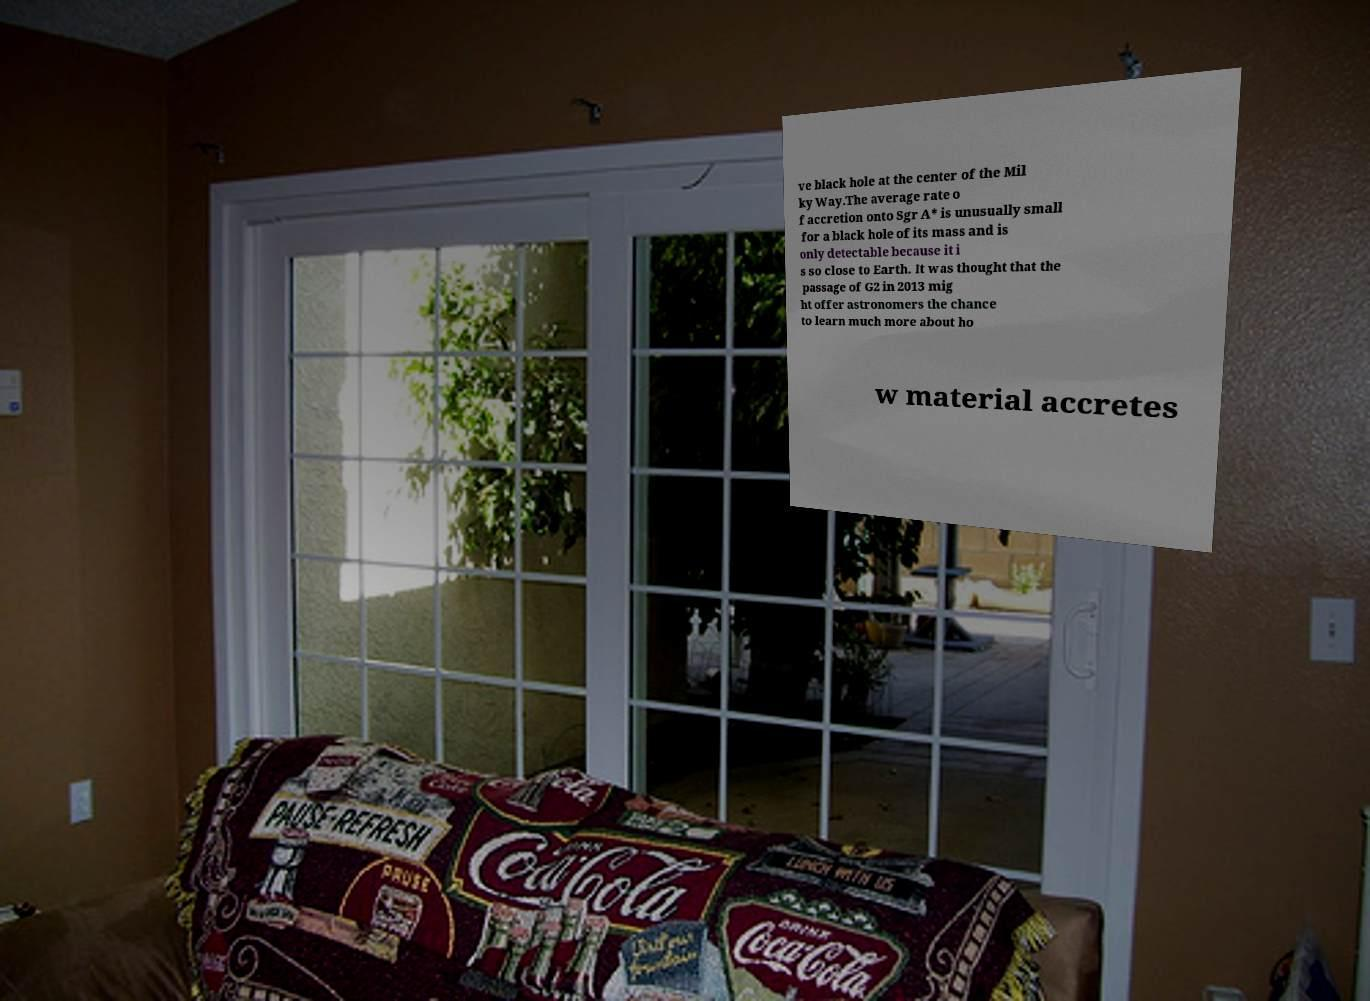Could you extract and type out the text from this image? ve black hole at the center of the Mil ky Way.The average rate o f accretion onto Sgr A* is unusually small for a black hole of its mass and is only detectable because it i s so close to Earth. It was thought that the passage of G2 in 2013 mig ht offer astronomers the chance to learn much more about ho w material accretes 